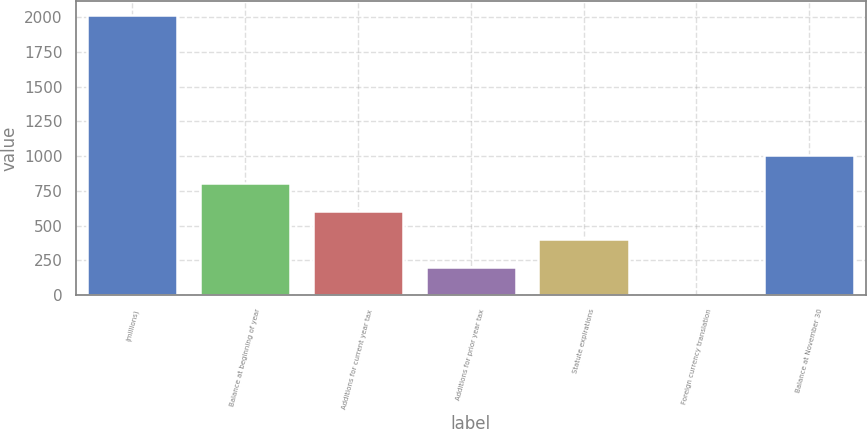Convert chart to OTSL. <chart><loc_0><loc_0><loc_500><loc_500><bar_chart><fcel>(millions)<fcel>Balance at beginning of year<fcel>Additions for current year tax<fcel>Additions for prior year tax<fcel>Statute expirations<fcel>Foreign currency translation<fcel>Balance at November 30<nl><fcel>2015<fcel>807.38<fcel>606.11<fcel>203.57<fcel>404.84<fcel>2.3<fcel>1008.65<nl></chart> 